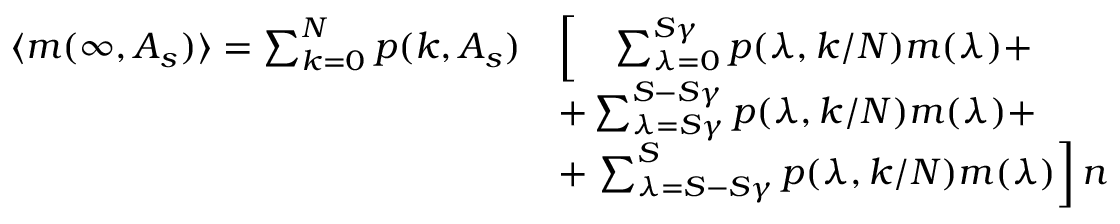<formula> <loc_0><loc_0><loc_500><loc_500>\begin{array} { r l } { \langle m ( \infty , A _ { s } ) \rangle = \sum _ { k = 0 } ^ { N } p ( k , A _ { s } ) } & { \left [ \quad \sum _ { \lambda = 0 } ^ { S \gamma } p ( \lambda , k / N ) m ( \lambda ) + } \\ & { + \sum _ { \lambda = S \gamma } ^ { S - S \gamma } p ( \lambda , k / N ) m ( \lambda ) + } \\ & { + \sum _ { \lambda = S - S \gamma } ^ { S } p ( \lambda , k / N ) m ( \lambda ) \right ] n } \end{array}</formula> 